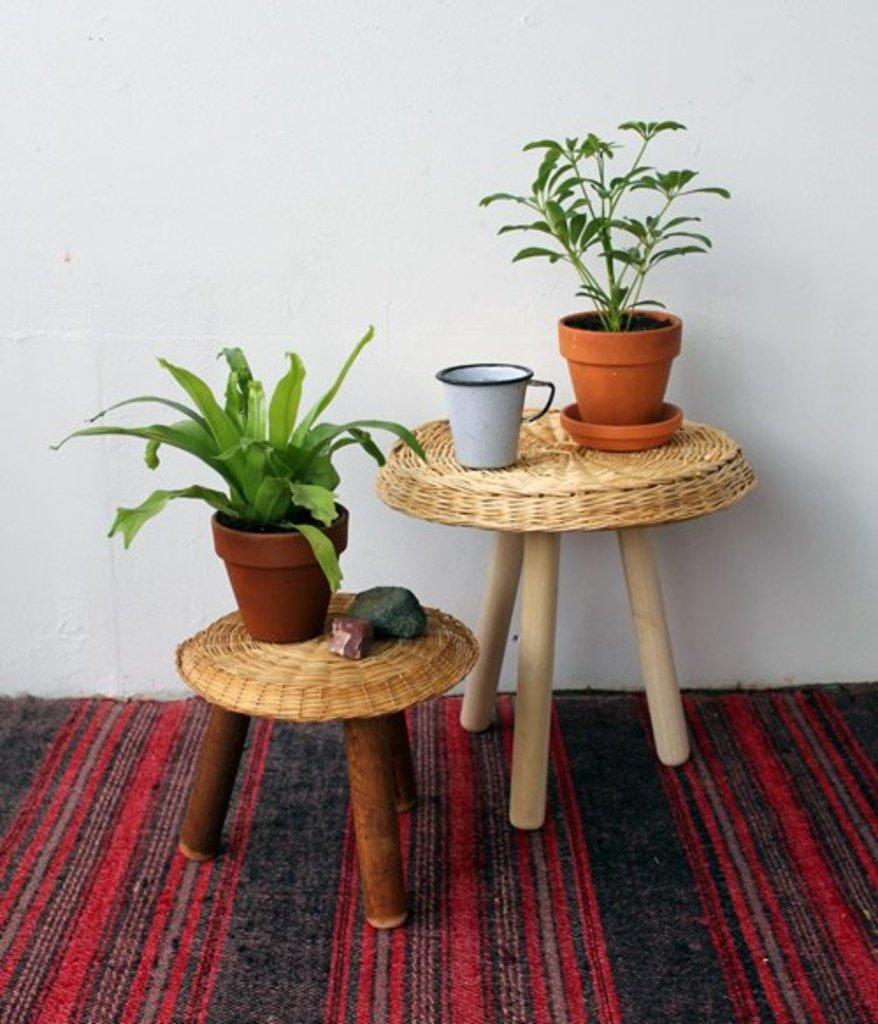How would you summarize this image in a sentence or two? This picture shows couple of plants on the tables and we see a cup 